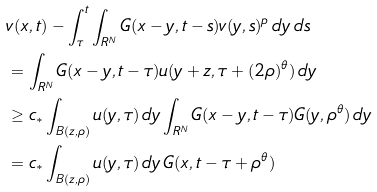Convert formula to latex. <formula><loc_0><loc_0><loc_500><loc_500>& v ( x , t ) - \int _ { \tau } ^ { t } \int _ { { R } ^ { N } } G ( x - y , t - s ) v ( y , s ) ^ { p } \, d y \, d s \\ & = \int _ { { R } ^ { N } } G ( x - y , t - \tau ) u ( y + z , \tau + ( 2 \rho ) ^ { \theta } ) \, d y \\ & \geq c _ { * } \int _ { B ( z , \rho ) } u ( y , \tau ) \, d y \int _ { { R } ^ { N } } G ( x - y , t - \tau ) G ( y , \rho ^ { \theta } ) \, d y \\ & = c _ { * } \int _ { B ( z , \rho ) } u ( y , \tau ) \, d y \, G ( x , t - \tau + \rho ^ { \theta } )</formula> 